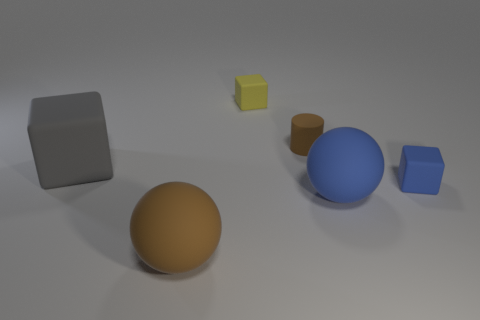Add 2 big gray things. How many objects exist? 8 Subtract all cylinders. How many objects are left? 5 Subtract all yellow objects. Subtract all brown objects. How many objects are left? 3 Add 6 large blue rubber objects. How many large blue rubber objects are left? 7 Add 3 brown matte things. How many brown matte things exist? 5 Subtract 1 blue balls. How many objects are left? 5 